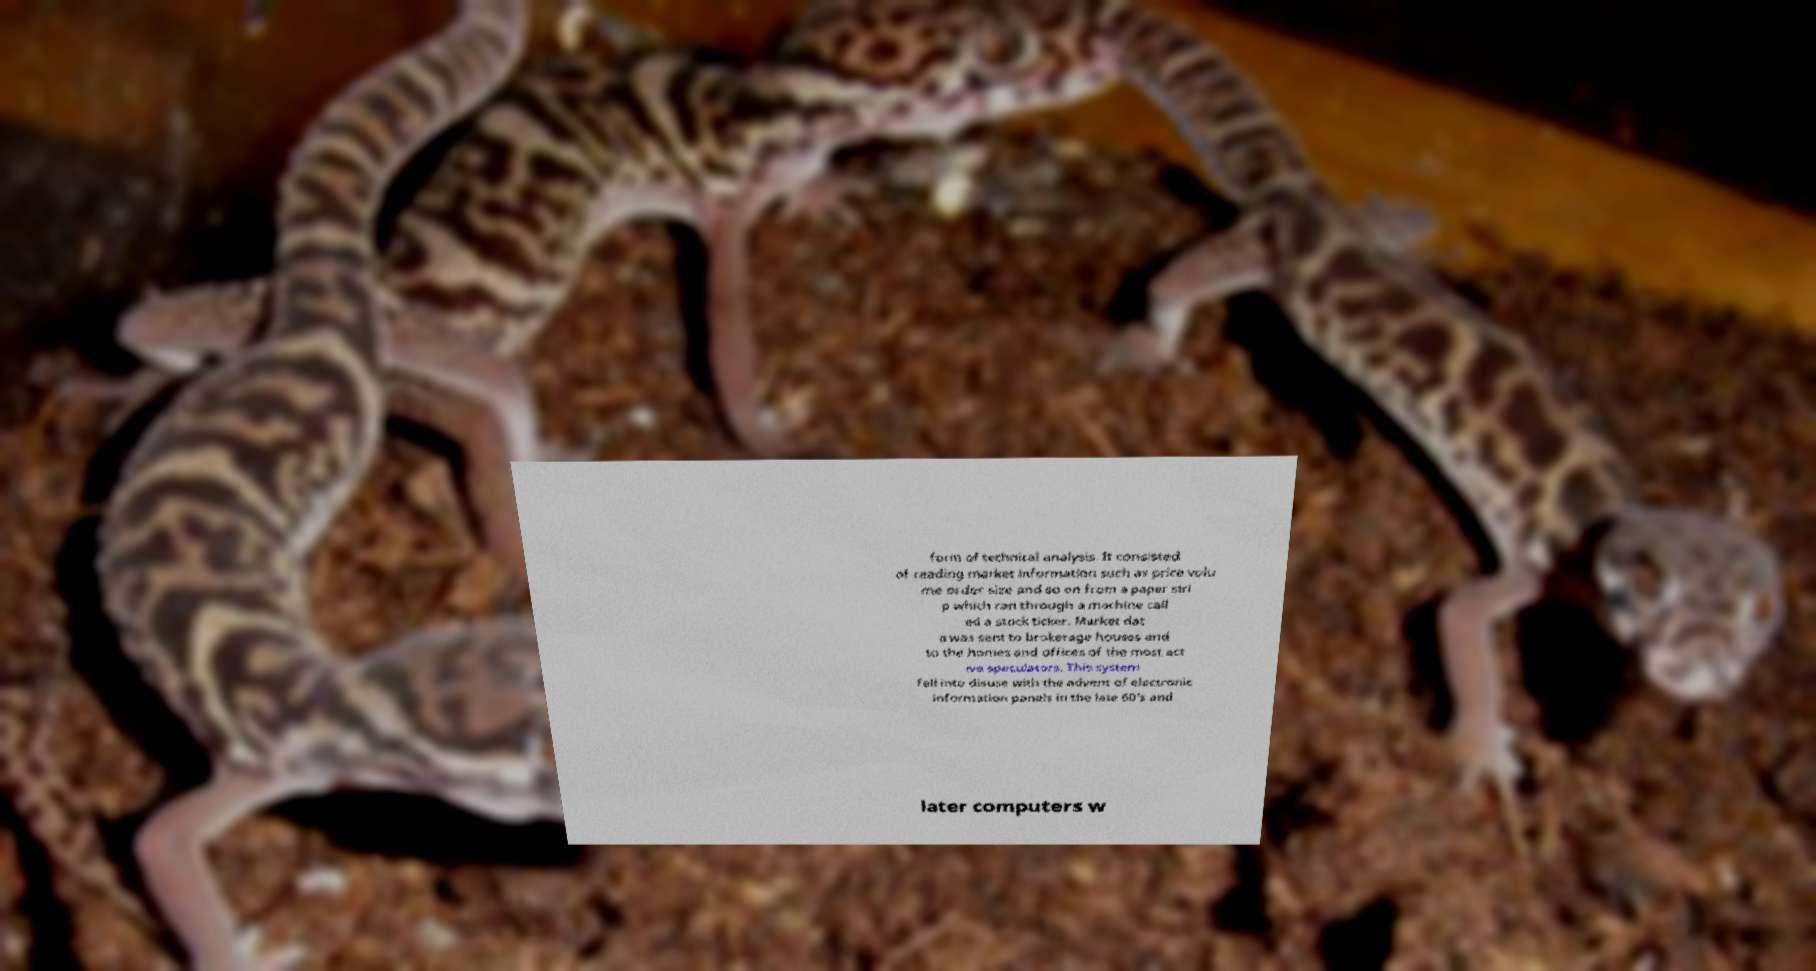For documentation purposes, I need the text within this image transcribed. Could you provide that? form of technical analysis. It consisted of reading market information such as price volu me order size and so on from a paper stri p which ran through a machine call ed a stock ticker. Market dat a was sent to brokerage houses and to the homes and offices of the most act ive speculators. This system fell into disuse with the advent of electronic information panels in the late 60's and later computers w 